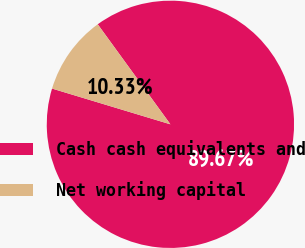Convert chart. <chart><loc_0><loc_0><loc_500><loc_500><pie_chart><fcel>Cash cash equivalents and<fcel>Net working capital<nl><fcel>89.67%<fcel>10.33%<nl></chart> 